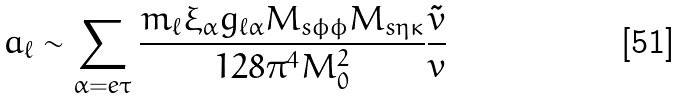<formula> <loc_0><loc_0><loc_500><loc_500>a _ { \ell } \sim \sum _ { \alpha = e \tau } \frac { m _ { \ell } \xi _ { \alpha } g _ { \ell \alpha } M _ { s \phi \phi } M _ { s \eta \kappa } } { 1 2 8 \pi ^ { 4 } M _ { 0 } ^ { 2 } } \frac { \tilde { v } } { v }</formula> 